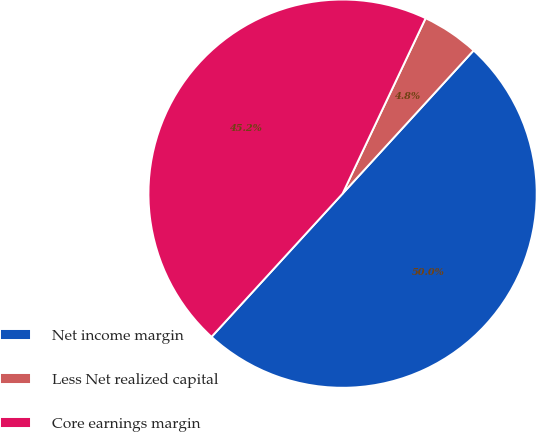Convert chart. <chart><loc_0><loc_0><loc_500><loc_500><pie_chart><fcel>Net income margin<fcel>Less Net realized capital<fcel>Core earnings margin<nl><fcel>50.0%<fcel>4.76%<fcel>45.24%<nl></chart> 